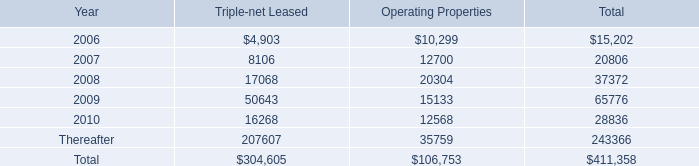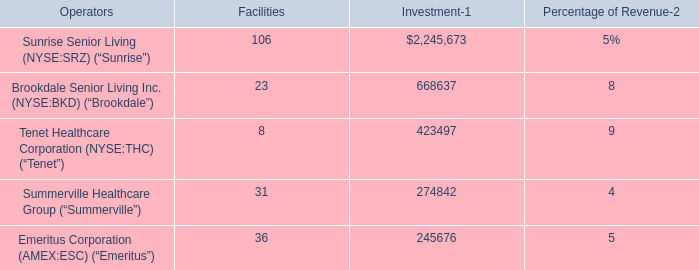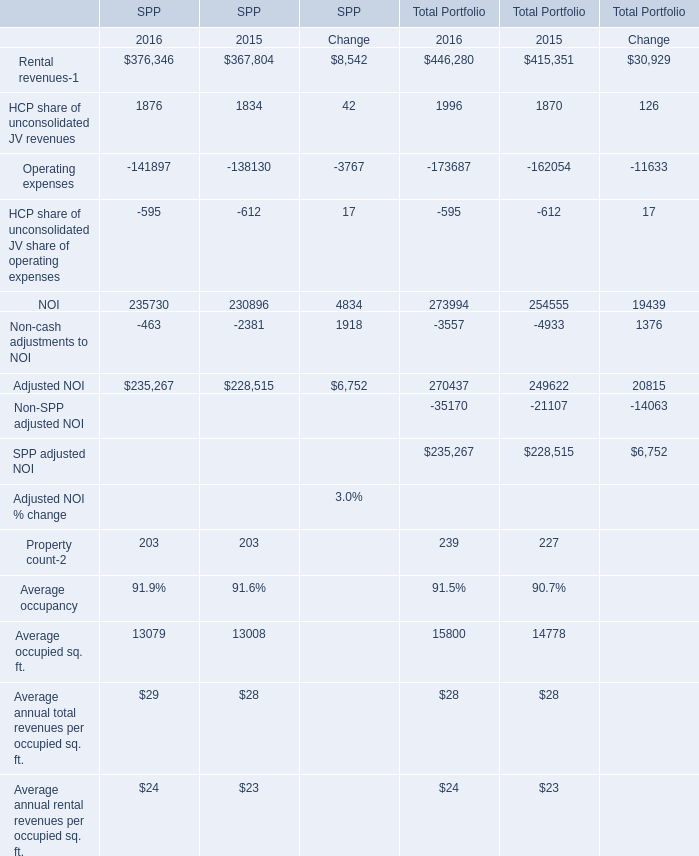What is the percentage of all SPP that are positive to the total amount, in 2015 for SPP? 
Computations: (((((((367804 + 1834) + 230896) + 228515) + 203) + 28) + 23) / (((((((((367804 + 1834) - 138130) - 612) + 230896) - 2381) + 228515) + 203) + 28) + 23))
Answer: 1.20507. 